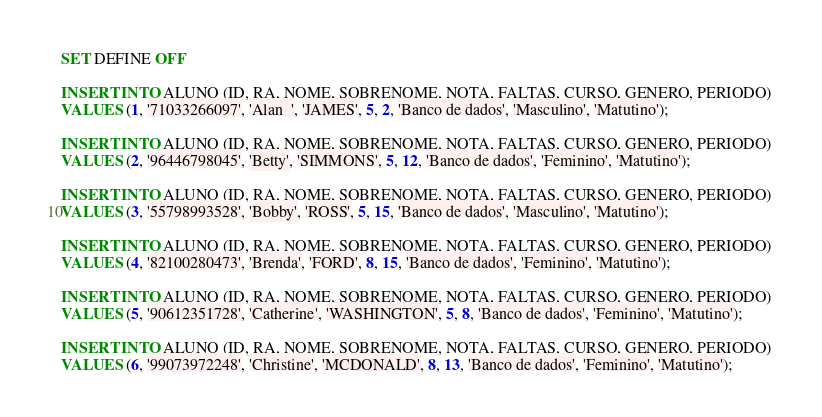<code> <loc_0><loc_0><loc_500><loc_500><_SQL_>SET DEFINE OFF

INSERT INTO ALUNO (ID, RA, NOME, SOBRENOME, NOTA, FALTAS, CURSO, GENERO, PERIODO) 
VALUES (1, '71033266097', 'Alan  ', 'JAMES', 5, 2, 'Banco de dados', 'Masculino', 'Matutino');

INSERT INTO ALUNO (ID, RA, NOME, SOBRENOME, NOTA, FALTAS, CURSO, GENERO, PERIODO) 
VALUES (2, '96446798045', 'Betty', 'SIMMONS', 5, 12, 'Banco de dados', 'Feminino', 'Matutino');

INSERT INTO ALUNO (ID, RA, NOME, SOBRENOME, NOTA, FALTAS, CURSO, GENERO, PERIODO) 
VALUES (3, '55798993528', 'Bobby', 'ROSS', 5, 15, 'Banco de dados', 'Masculino', 'Matutino');

INSERT INTO ALUNO (ID, RA, NOME, SOBRENOME, NOTA, FALTAS, CURSO, GENERO, PERIODO) 
VALUES (4, '82100280473', 'Brenda', 'FORD', 8, 15, 'Banco de dados', 'Feminino', 'Matutino');

INSERT INTO ALUNO (ID, RA, NOME, SOBRENOME, NOTA, FALTAS, CURSO, GENERO, PERIODO) 
VALUES (5, '90612351728', 'Catherine', 'WASHINGTON', 5, 8, 'Banco de dados', 'Feminino', 'Matutino');

INSERT INTO ALUNO (ID, RA, NOME, SOBRENOME, NOTA, FALTAS, CURSO, GENERO, PERIODO) 
VALUES (6, '99073972248', 'Christine', 'MCDONALD', 8, 13, 'Banco de dados', 'Feminino', 'Matutino');
</code> 